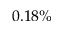Convert formula to latex. <formula><loc_0><loc_0><loc_500><loc_500>0 . 1 8 \%</formula> 